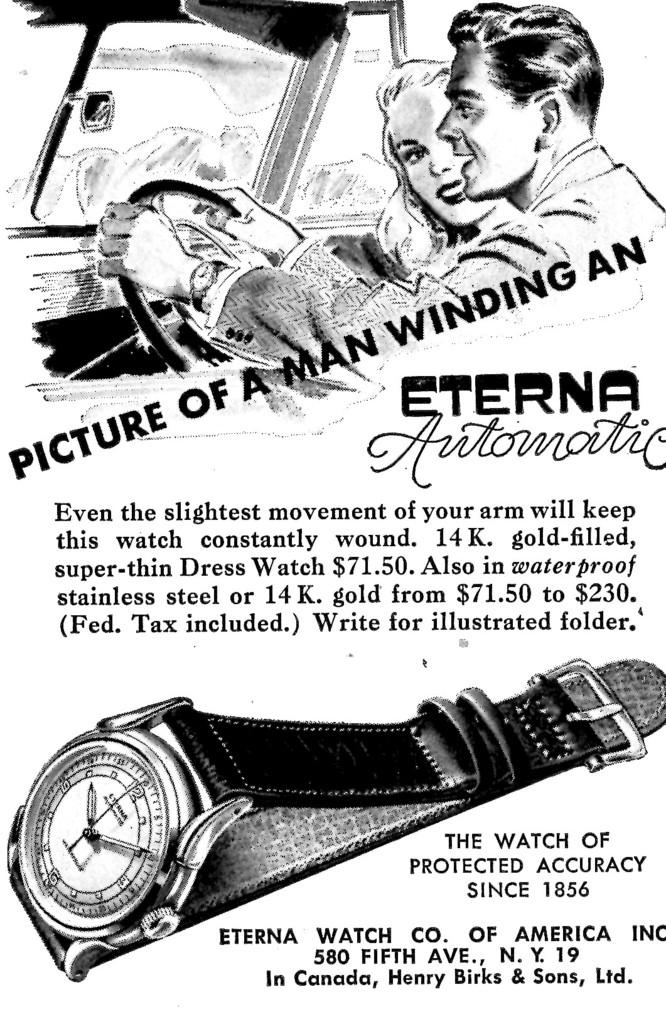<image>
Write a terse but informative summary of the picture. An advertisement for the Eterna Watch Company is in black and white. 